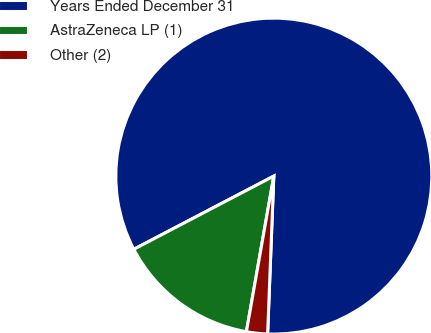<chart> <loc_0><loc_0><loc_500><loc_500><pie_chart><fcel>Years Ended December 31<fcel>AstraZeneca LP (1)<fcel>Other (2)<nl><fcel>83.29%<fcel>14.56%<fcel>2.15%<nl></chart> 